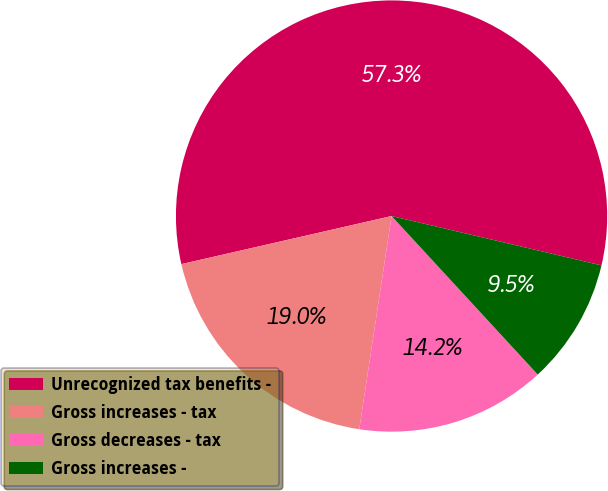<chart> <loc_0><loc_0><loc_500><loc_500><pie_chart><fcel>Unrecognized tax benefits -<fcel>Gross increases - tax<fcel>Gross decreases - tax<fcel>Gross increases -<nl><fcel>57.26%<fcel>19.03%<fcel>14.25%<fcel>9.47%<nl></chart> 